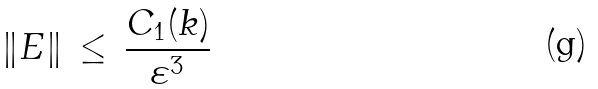Convert formula to latex. <formula><loc_0><loc_0><loc_500><loc_500>\| E \| \, \leq \, \frac { C _ { 1 } ( k ) } { \varepsilon ^ { 3 } }</formula> 